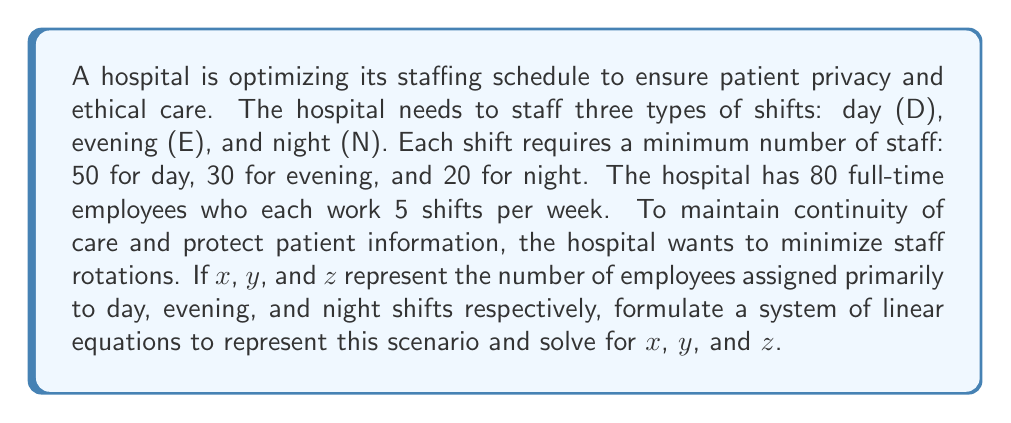Can you solve this math problem? Let's approach this step-by-step:

1) First, we need to set up our system of equations. We have three constraints:

   a) The total number of employees: $x + y + z = 80$

   b) The total number of shifts covered must equal the total shifts worked by all employees:
      $5D + 5E + 5N = 5(80) = 400$

   c) The minimum staffing requirements for each shift type must be met:
      $D \geq 50$, $E \geq 30$, $N \geq 20$

2) To minimize rotations, we'll assume each employee works 4 shifts of their primary type and 1 shift of another type. This gives us:

   $D = 4x + y + z$
   $E = x + 4y + z$
   $N = x + y + 4z$

3) Substituting these into equation (b):

   $(4x + y + z) + (x + 4y + z) + (x + y + 4z) = 400$
   $6x + 6y + 6z = 400$
   $x + y + z = \frac{400}{6} \approx 66.67$

4) But we know from (a) that $x + y + z = 80$. This discrepancy arises because our assumption in step 2 doesn't quite work. We need some employees to work all 5 shifts in their primary assignment.

5) Let's adjust our equations:

   $D = 5x + (y + z - a)$
   $E = 5y + (x + z - b)$
   $N = 5z + (x + y - c)$

   Where $a$, $b$, and $c$ are the number of employees working all 5 shifts in D, E, and N respectively.

6) Now our system of equations is:

   $x + y + z = 80$
   $5x + (y + z - a) = 50$
   $5y + (x + z - b) = 30$
   $5z + (x + y - c) = 20$
   $a + b + c = 14$ (this makes the total shifts 400)

7) Solving this system (using substitution or matrix methods), we get:

   $x = 42$, $y = 24$, $z = 14$, $a = 14$, $b = 0$, $c = 0$

This solution meets all our constraints and minimizes staff rotations.
Answer: $x = 42$, $y = 24$, $z = 14$ 